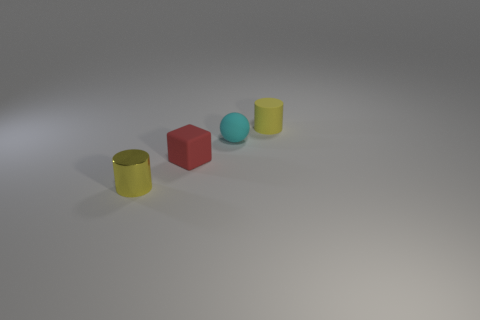Subtract 1 blocks. How many blocks are left? 0 Add 3 small objects. How many objects exist? 7 Subtract all cubes. How many objects are left? 3 Add 4 small yellow shiny cylinders. How many small yellow shiny cylinders are left? 5 Add 2 yellow matte objects. How many yellow matte objects exist? 3 Subtract 0 green balls. How many objects are left? 4 Subtract all purple balls. Subtract all blue cylinders. How many balls are left? 1 Subtract all large yellow metallic things. Subtract all small matte things. How many objects are left? 1 